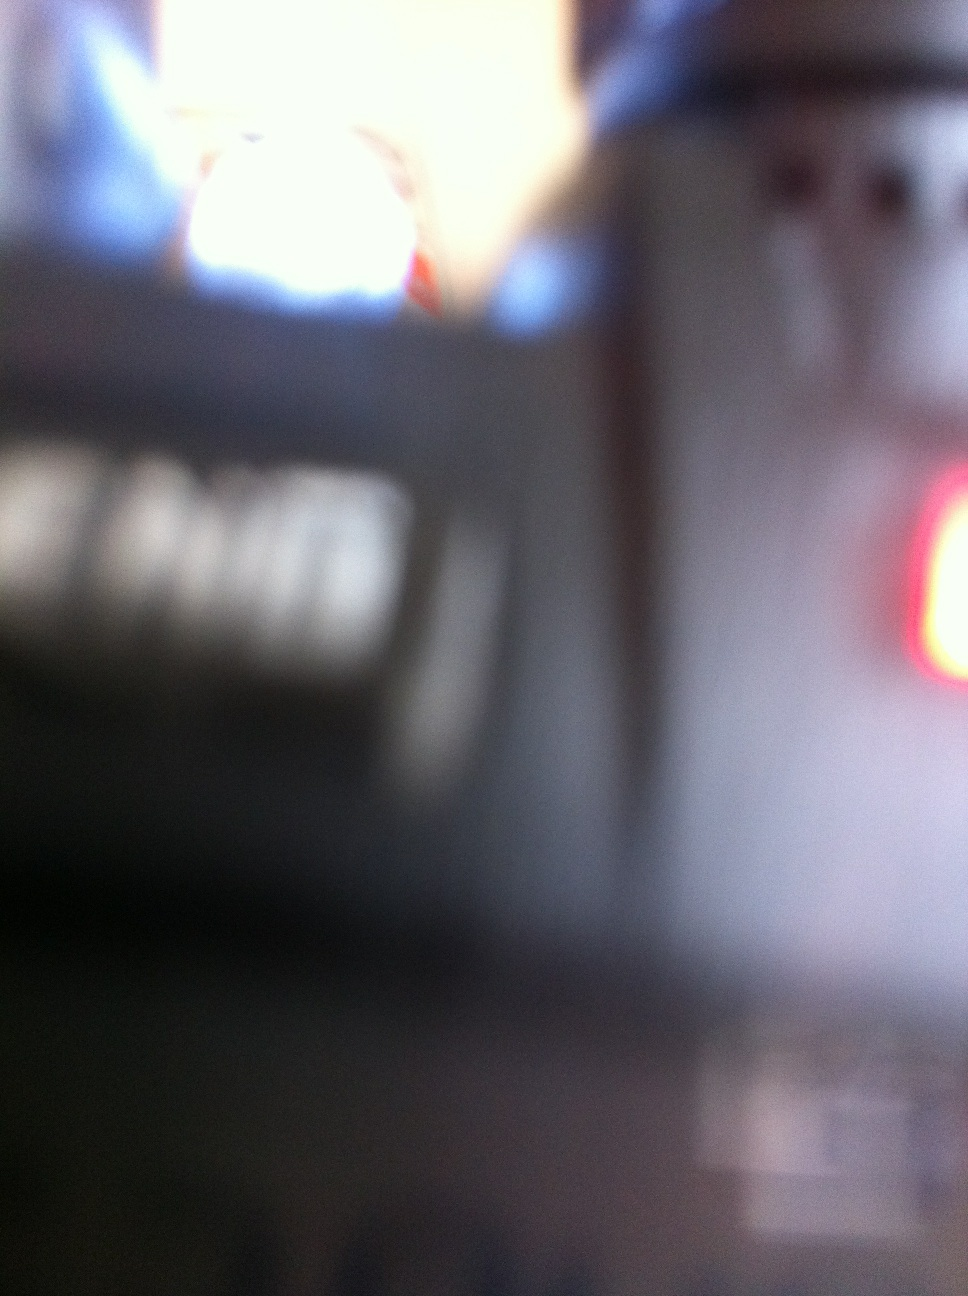What could be the reason for the image being blurred? The blurriness of the image could be due to several factors, such as the camera being out of focus, a quick movement during the shot, or low lighting conditions. This typically makes it difficult to capture detailed or clear photos. 